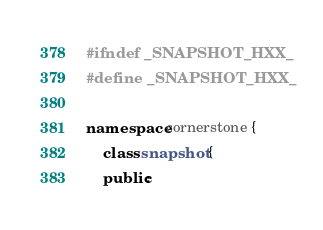Convert code to text. <code><loc_0><loc_0><loc_500><loc_500><_C++_>#ifndef _SNAPSHOT_HXX_
#define _SNAPSHOT_HXX_

namespace cornerstone {
    class snapshot {
    public:</code> 